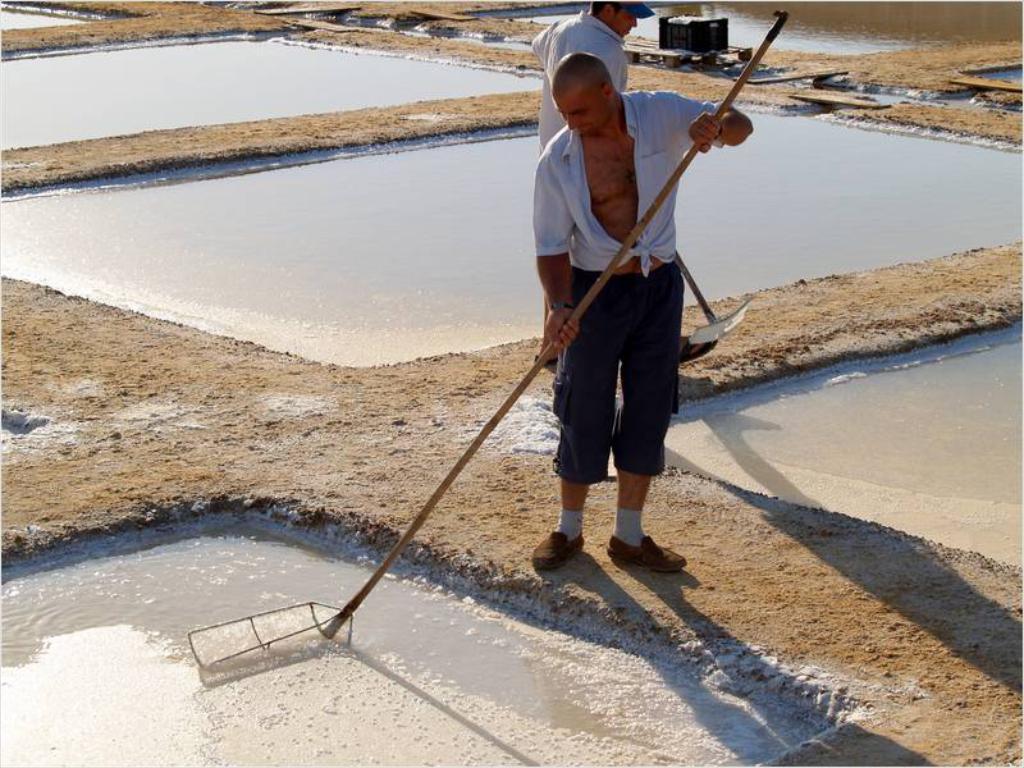How would you summarize this image in a sentence or two? In the foreground of this picture, there is a man standing on the field holding a stick in his hand. Behind him, there is another person standing and holding an object. In the background, there is water, ground and a box. This image seems like they are preparing salt. 